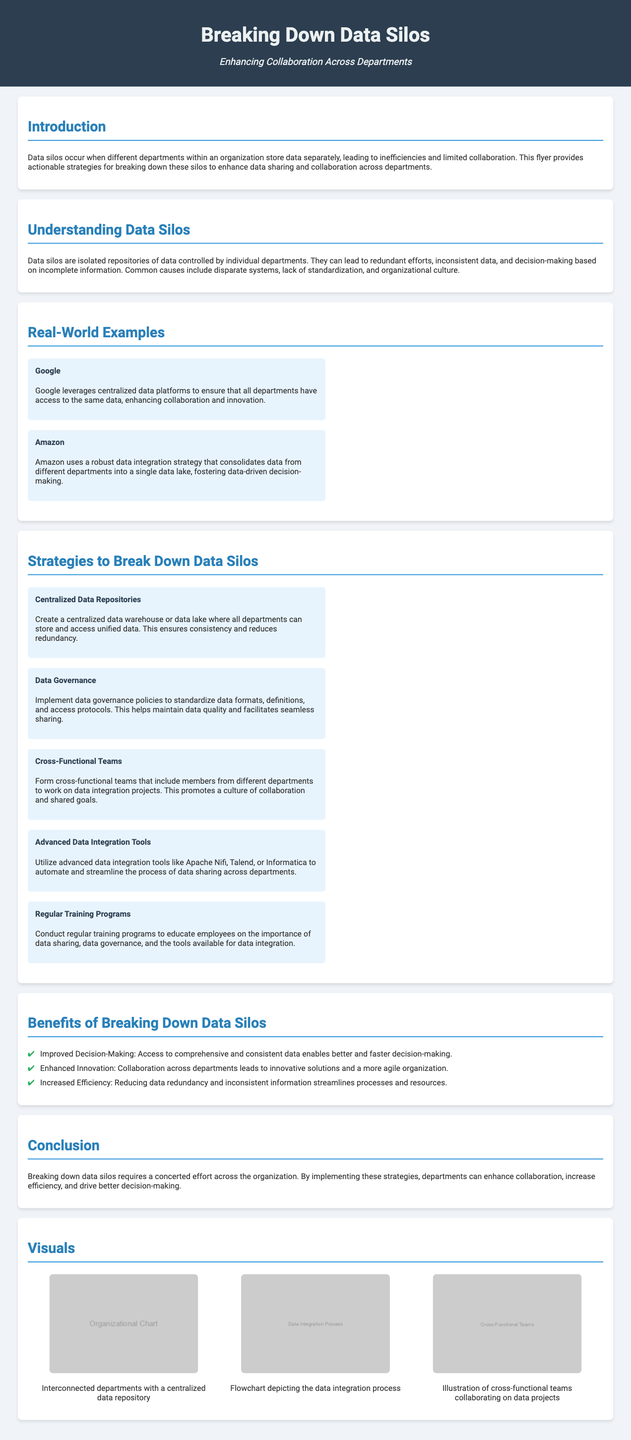What is the title of the flyer? The title of the flyer is presented prominently at the top, indicating the subject matter.
Answer: Breaking Down Data Silos What are two companies mentioned as examples in the flyer? The flyer lists two prominent companies as real-world examples of overcoming data silos.
Answer: Google, Amazon What is one strategy for breaking down data silos? The flyer outlines various strategies in a section dedicated to this topic, providing actionable ideas.
Answer: Centralized Data Repositories What benefit is associated with breaking down data silos? The flyer lists several benefits in a dedicated section outlining the positive outcomes of implementing strategies.
Answer: Improved Decision-Making How many examples of companies are provided in the flyer? The document presents a specific number of examples in the real-world section, highlighting industry practices.
Answer: Two What is one tool mentioned for data integration? The flyer specifies advanced tools that can be utilized for data integration, aiming to streamline processes.
Answer: Apache Nifi What type of teams can enhance collaboration according to the document? The flyer suggests a specific arrangement of teams that promotes collaboration across departments.
Answer: Cross-Functional Teams How many sections are there in the document? The overall structure of the document includes distinct sections, each tackling different aspects of the topic.
Answer: Seven 